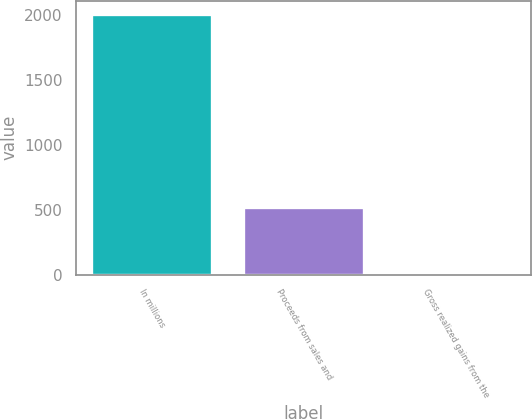Convert chart to OTSL. <chart><loc_0><loc_0><loc_500><loc_500><bar_chart><fcel>In millions<fcel>Proceeds from sales and<fcel>Gross realized gains from the<nl><fcel>2013<fcel>525<fcel>14<nl></chart> 